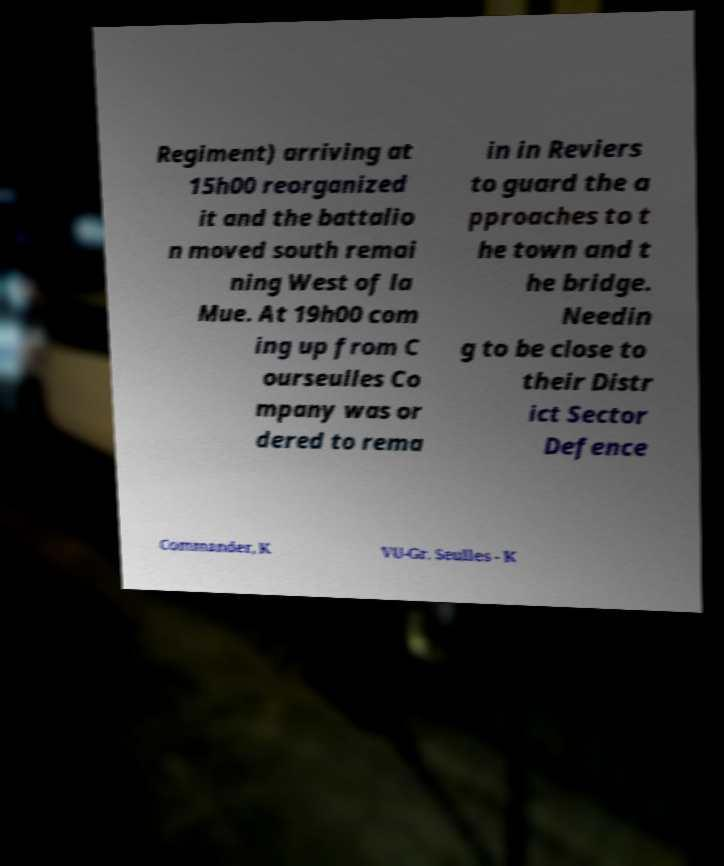Could you extract and type out the text from this image? Regiment) arriving at 15h00 reorganized it and the battalio n moved south remai ning West of la Mue. At 19h00 com ing up from C ourseulles Co mpany was or dered to rema in in Reviers to guard the a pproaches to t he town and t he bridge. Needin g to be close to their Distr ict Sector Defence Commander, K VU-Gr. Seulles - K 